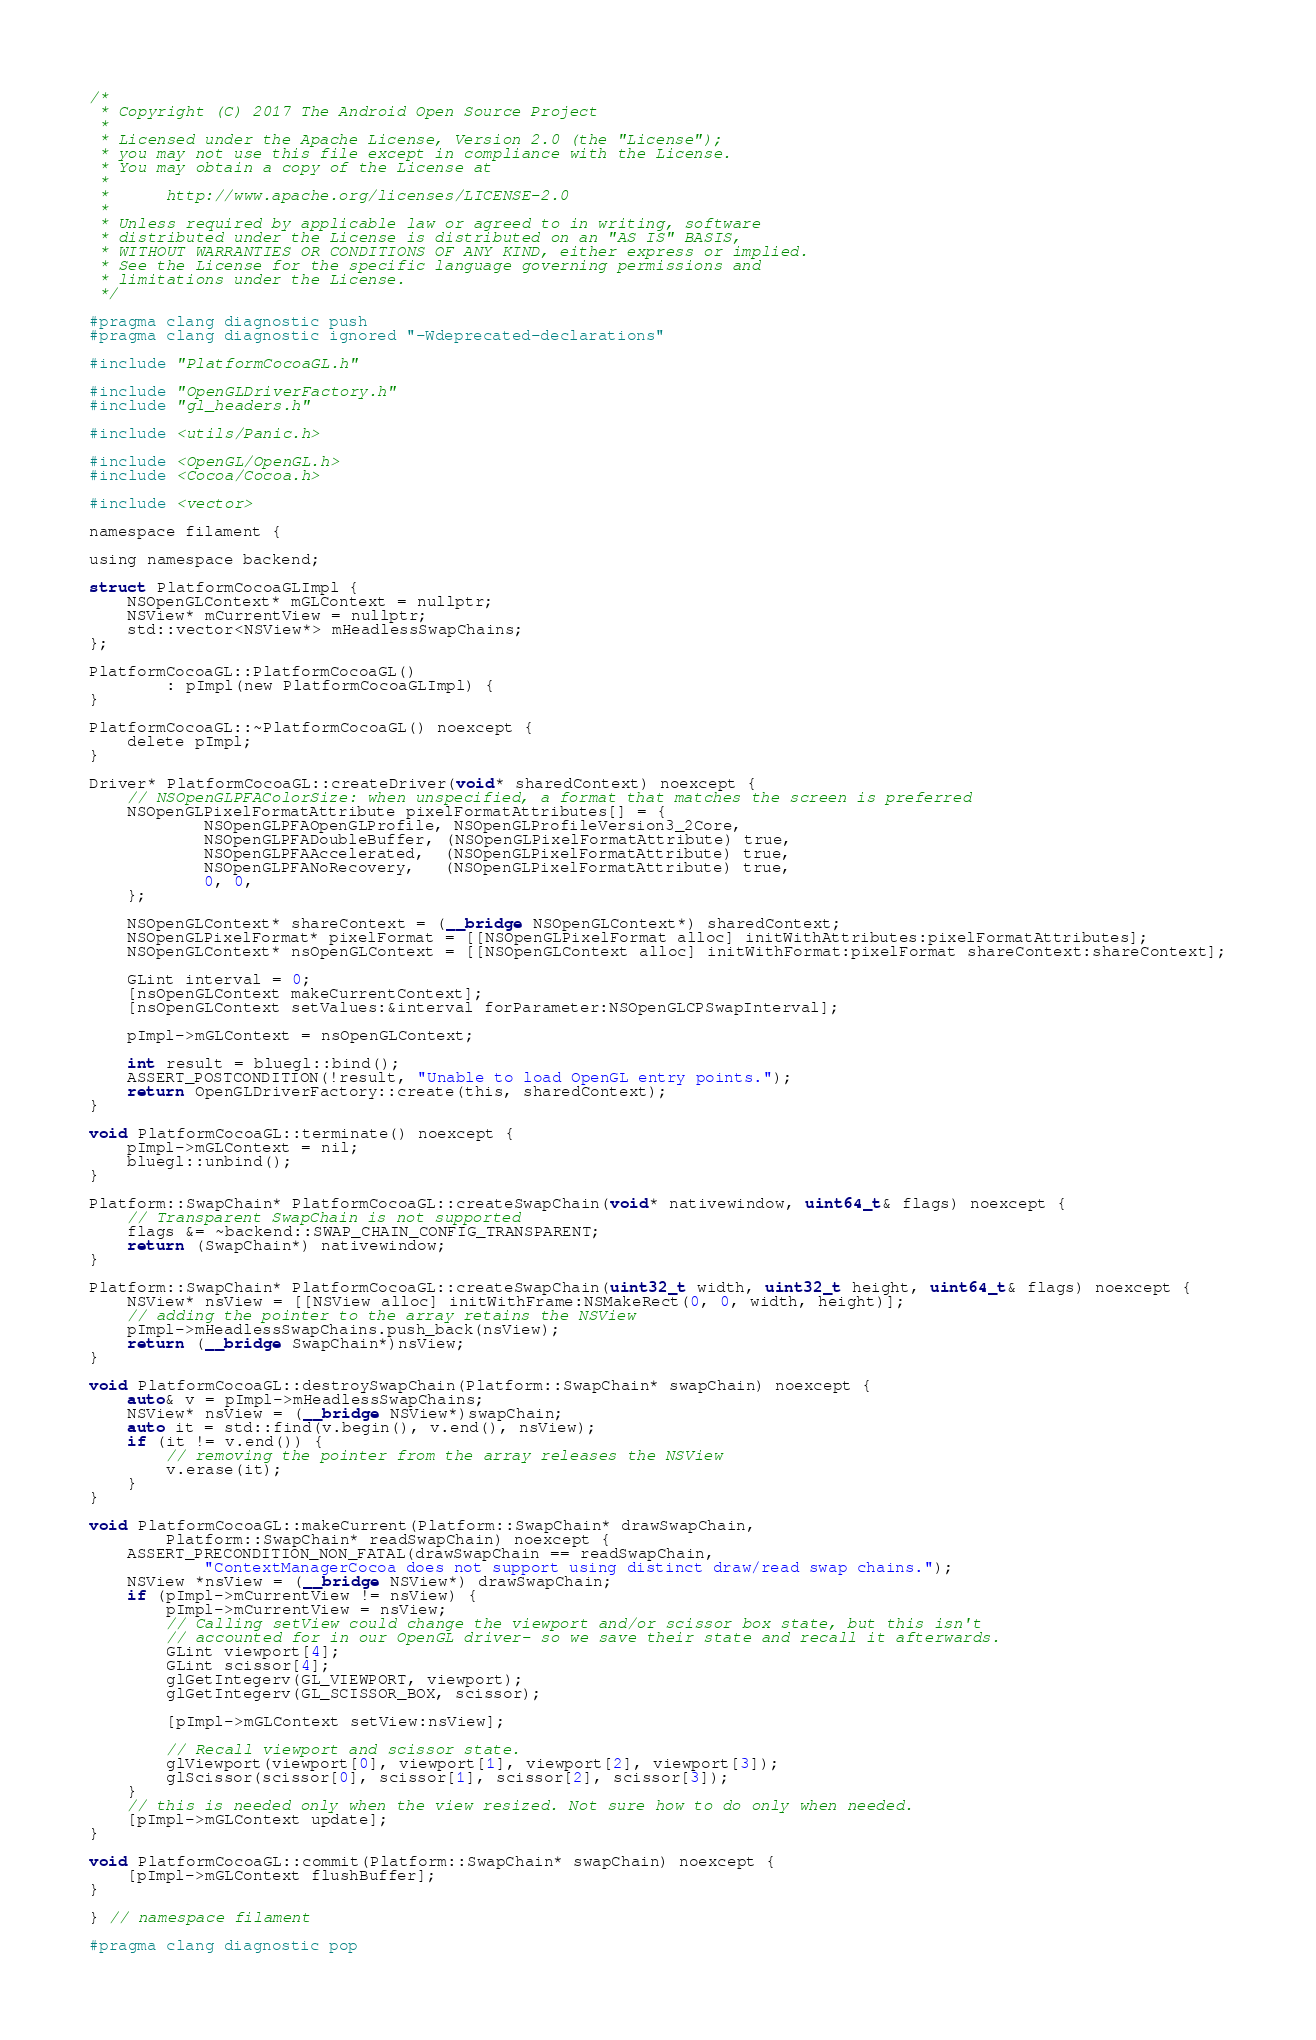<code> <loc_0><loc_0><loc_500><loc_500><_ObjectiveC_>/*
 * Copyright (C) 2017 The Android Open Source Project
 *
 * Licensed under the Apache License, Version 2.0 (the "License");
 * you may not use this file except in compliance with the License.
 * You may obtain a copy of the License at
 *
 *      http://www.apache.org/licenses/LICENSE-2.0
 *
 * Unless required by applicable law or agreed to in writing, software
 * distributed under the License is distributed on an "AS IS" BASIS,
 * WITHOUT WARRANTIES OR CONDITIONS OF ANY KIND, either express or implied.
 * See the License for the specific language governing permissions and
 * limitations under the License.
 */

#pragma clang diagnostic push
#pragma clang diagnostic ignored "-Wdeprecated-declarations"

#include "PlatformCocoaGL.h"

#include "OpenGLDriverFactory.h"
#include "gl_headers.h"

#include <utils/Panic.h>

#include <OpenGL/OpenGL.h>
#include <Cocoa/Cocoa.h>

#include <vector>

namespace filament {

using namespace backend;

struct PlatformCocoaGLImpl {
    NSOpenGLContext* mGLContext = nullptr;
    NSView* mCurrentView = nullptr;
    std::vector<NSView*> mHeadlessSwapChains;
};

PlatformCocoaGL::PlatformCocoaGL()
        : pImpl(new PlatformCocoaGLImpl) {
}

PlatformCocoaGL::~PlatformCocoaGL() noexcept {
    delete pImpl;
}

Driver* PlatformCocoaGL::createDriver(void* sharedContext) noexcept {
    // NSOpenGLPFAColorSize: when unspecified, a format that matches the screen is preferred
    NSOpenGLPixelFormatAttribute pixelFormatAttributes[] = {
            NSOpenGLPFAOpenGLProfile, NSOpenGLProfileVersion3_2Core,
            NSOpenGLPFADoubleBuffer, (NSOpenGLPixelFormatAttribute) true,
            NSOpenGLPFAAccelerated,  (NSOpenGLPixelFormatAttribute) true,
            NSOpenGLPFANoRecovery,   (NSOpenGLPixelFormatAttribute) true,
            0, 0,
    };

    NSOpenGLContext* shareContext = (__bridge NSOpenGLContext*) sharedContext;
    NSOpenGLPixelFormat* pixelFormat = [[NSOpenGLPixelFormat alloc] initWithAttributes:pixelFormatAttributes];
    NSOpenGLContext* nsOpenGLContext = [[NSOpenGLContext alloc] initWithFormat:pixelFormat shareContext:shareContext];

    GLint interval = 0;
    [nsOpenGLContext makeCurrentContext];
    [nsOpenGLContext setValues:&interval forParameter:NSOpenGLCPSwapInterval];

    pImpl->mGLContext = nsOpenGLContext;

    int result = bluegl::bind();
    ASSERT_POSTCONDITION(!result, "Unable to load OpenGL entry points.");
    return OpenGLDriverFactory::create(this, sharedContext);
}

void PlatformCocoaGL::terminate() noexcept {
    pImpl->mGLContext = nil;
    bluegl::unbind();
}

Platform::SwapChain* PlatformCocoaGL::createSwapChain(void* nativewindow, uint64_t& flags) noexcept {
    // Transparent SwapChain is not supported
    flags &= ~backend::SWAP_CHAIN_CONFIG_TRANSPARENT;
    return (SwapChain*) nativewindow;
}

Platform::SwapChain* PlatformCocoaGL::createSwapChain(uint32_t width, uint32_t height, uint64_t& flags) noexcept {
    NSView* nsView = [[NSView alloc] initWithFrame:NSMakeRect(0, 0, width, height)];
    // adding the pointer to the array retains the NSView
    pImpl->mHeadlessSwapChains.push_back(nsView);
    return (__bridge SwapChain*)nsView;
}

void PlatformCocoaGL::destroySwapChain(Platform::SwapChain* swapChain) noexcept {
    auto& v = pImpl->mHeadlessSwapChains;
    NSView* nsView = (__bridge NSView*)swapChain;
    auto it = std::find(v.begin(), v.end(), nsView);
    if (it != v.end()) {
        // removing the pointer from the array releases the NSView
        v.erase(it);
    }
}

void PlatformCocoaGL::makeCurrent(Platform::SwapChain* drawSwapChain,
        Platform::SwapChain* readSwapChain) noexcept {
    ASSERT_PRECONDITION_NON_FATAL(drawSwapChain == readSwapChain,
            "ContextManagerCocoa does not support using distinct draw/read swap chains.");
    NSView *nsView = (__bridge NSView*) drawSwapChain;
    if (pImpl->mCurrentView != nsView) {
        pImpl->mCurrentView = nsView;
        // Calling setView could change the viewport and/or scissor box state, but this isn't
        // accounted for in our OpenGL driver- so we save their state and recall it afterwards.
        GLint viewport[4];
        GLint scissor[4];
        glGetIntegerv(GL_VIEWPORT, viewport);
        glGetIntegerv(GL_SCISSOR_BOX, scissor);

        [pImpl->mGLContext setView:nsView];

        // Recall viewport and scissor state.
        glViewport(viewport[0], viewport[1], viewport[2], viewport[3]);
        glScissor(scissor[0], scissor[1], scissor[2], scissor[3]);
    }
    // this is needed only when the view resized. Not sure how to do only when needed.
    [pImpl->mGLContext update];
}

void PlatformCocoaGL::commit(Platform::SwapChain* swapChain) noexcept {
    [pImpl->mGLContext flushBuffer];
}

} // namespace filament

#pragma clang diagnostic pop
</code> 